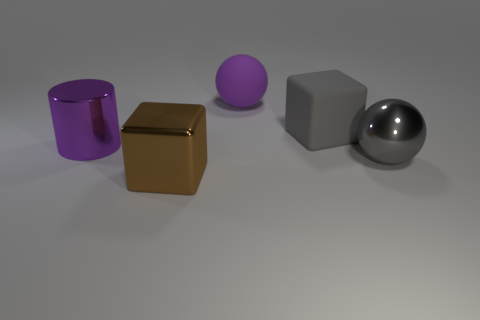Add 1 blue shiny cubes. How many objects exist? 6 Subtract all blocks. How many objects are left? 3 Subtract all small brown objects. Subtract all cubes. How many objects are left? 3 Add 5 brown metal things. How many brown metal things are left? 6 Add 1 large purple matte balls. How many large purple matte balls exist? 2 Subtract 0 red cylinders. How many objects are left? 5 Subtract all gray blocks. Subtract all gray cylinders. How many blocks are left? 1 